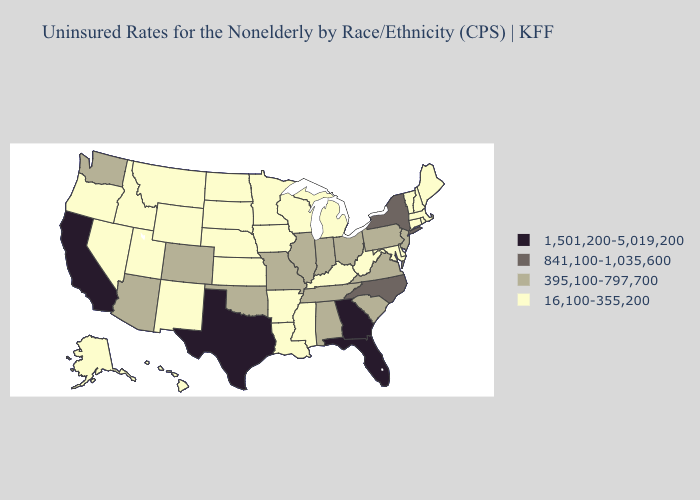What is the lowest value in the USA?
Concise answer only. 16,100-355,200. What is the lowest value in the South?
Concise answer only. 16,100-355,200. What is the lowest value in the Northeast?
Be succinct. 16,100-355,200. Does Nevada have the lowest value in the West?
Quick response, please. Yes. What is the highest value in the USA?
Give a very brief answer. 1,501,200-5,019,200. Which states hav the highest value in the Northeast?
Concise answer only. New York. Does the first symbol in the legend represent the smallest category?
Short answer required. No. Among the states that border New Jersey , does New York have the lowest value?
Give a very brief answer. No. Among the states that border New Hampshire , which have the highest value?
Concise answer only. Maine, Massachusetts, Vermont. Name the states that have a value in the range 841,100-1,035,600?
Give a very brief answer. New York, North Carolina. Does West Virginia have the highest value in the South?
Write a very short answer. No. What is the lowest value in the USA?
Quick response, please. 16,100-355,200. Does Wisconsin have the same value as Utah?
Concise answer only. Yes. 